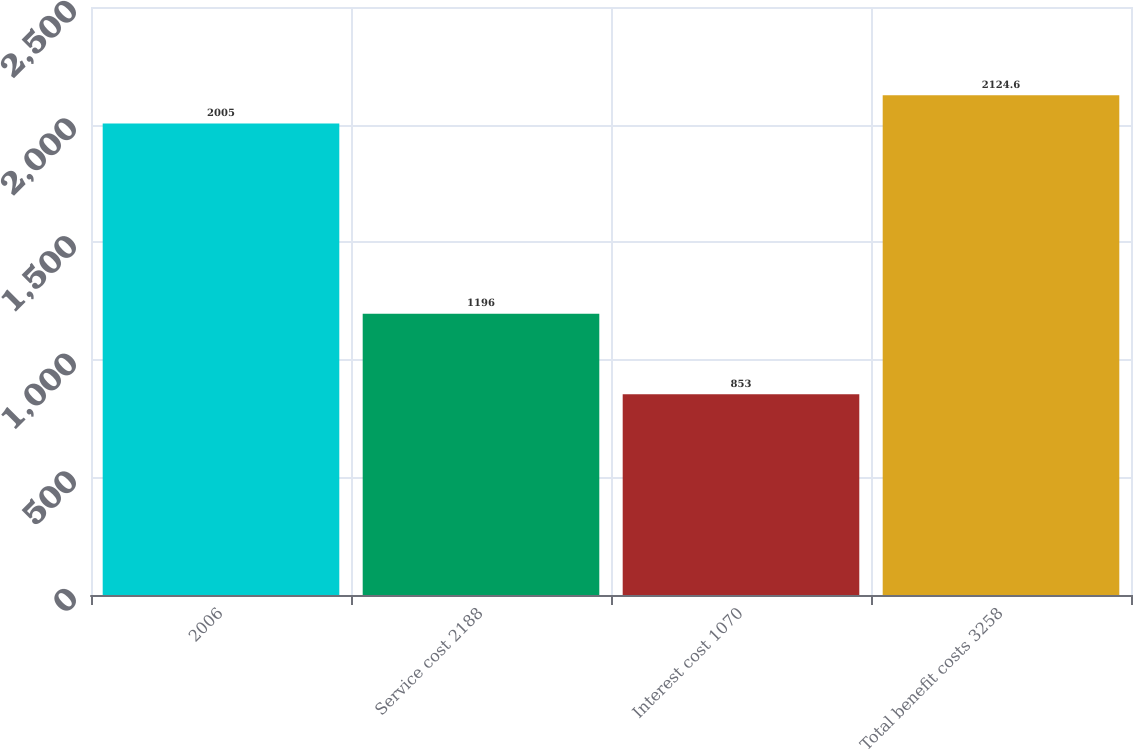<chart> <loc_0><loc_0><loc_500><loc_500><bar_chart><fcel>2006<fcel>Service cost 2188<fcel>Interest cost 1070<fcel>Total benefit costs 3258<nl><fcel>2005<fcel>1196<fcel>853<fcel>2124.6<nl></chart> 